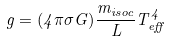Convert formula to latex. <formula><loc_0><loc_0><loc_500><loc_500>g = ( 4 \pi \sigma G ) \frac { m _ { i s o c } } { L } T _ { e f f } ^ { 4 }</formula> 